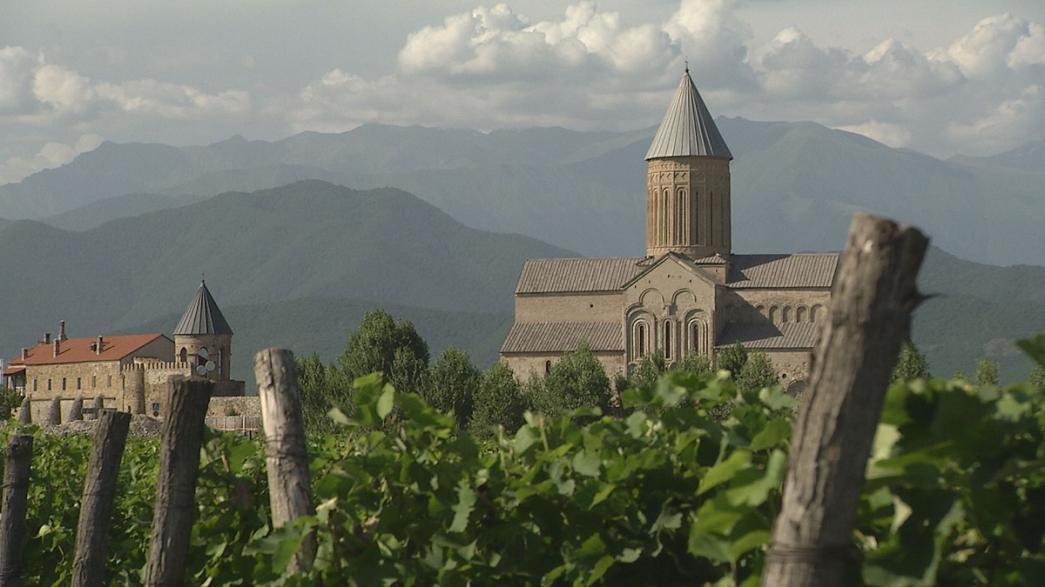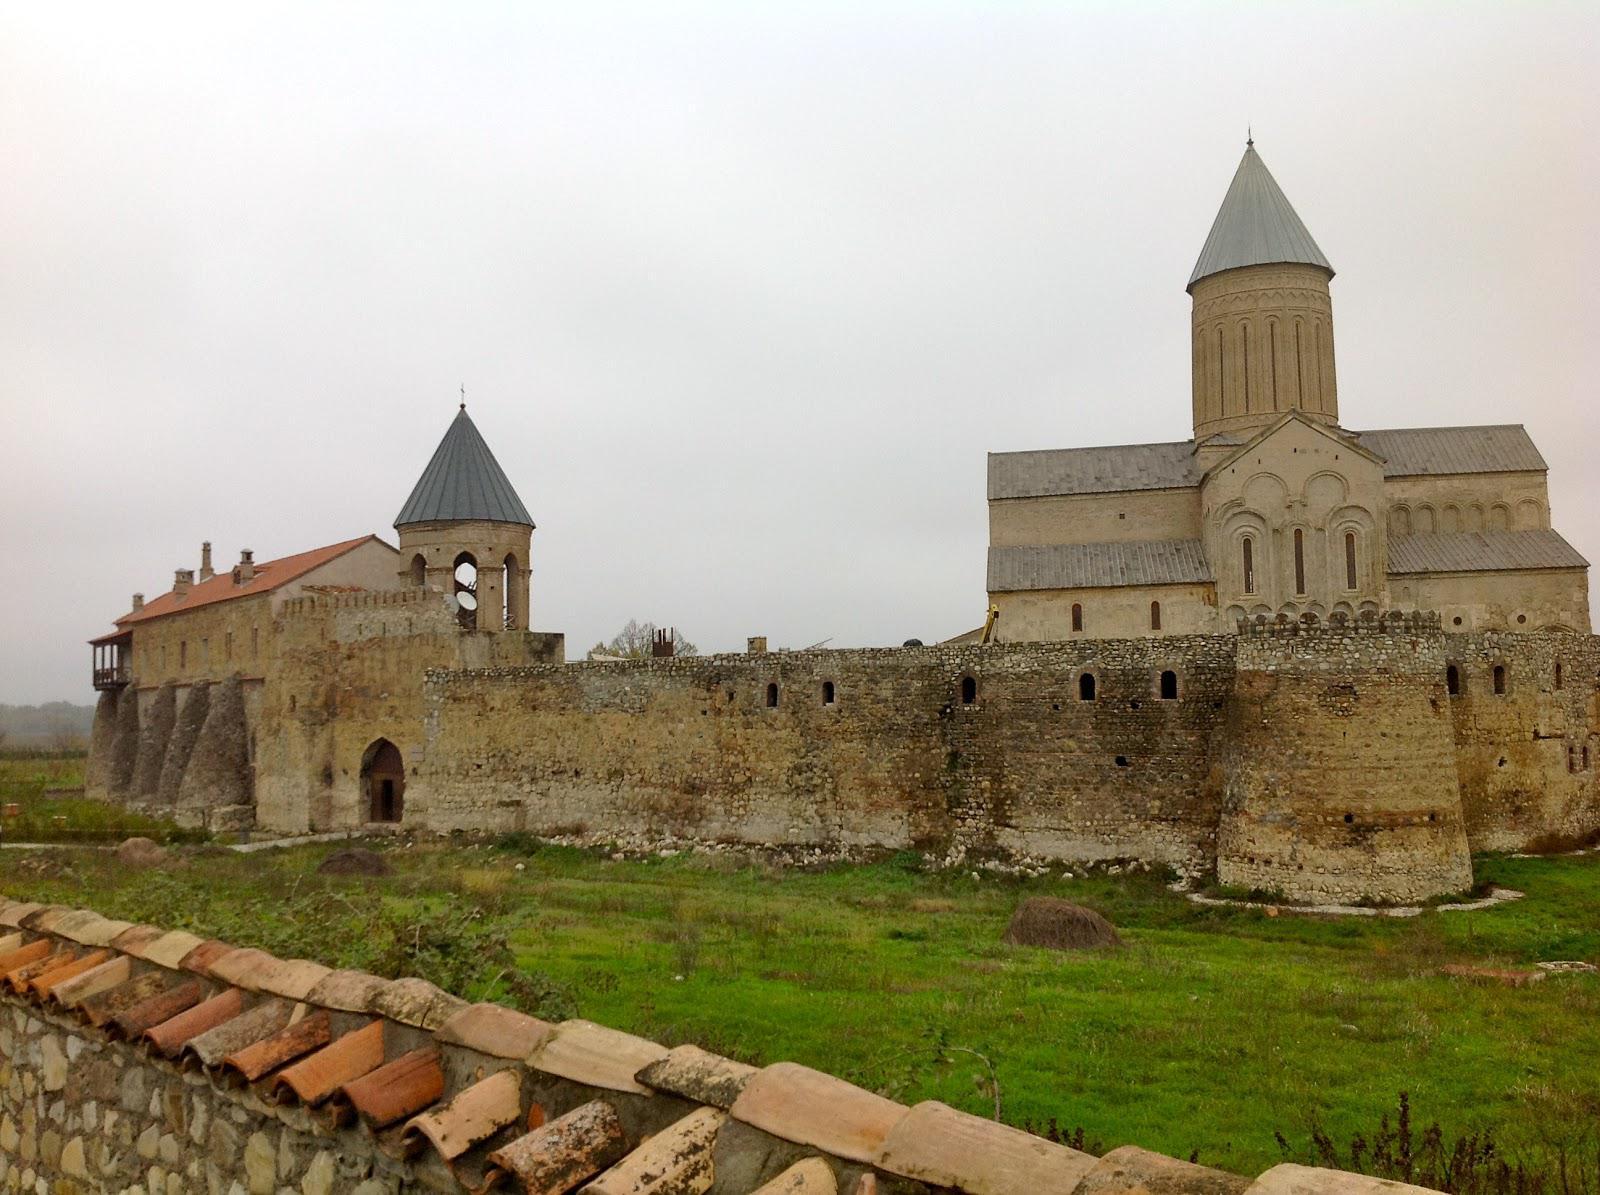The first image is the image on the left, the second image is the image on the right. Analyze the images presented: Is the assertion "In at least one image there are at least two triangle towers roofs behind a cobblestone wall." valid? Answer yes or no. Yes. The first image is the image on the left, the second image is the image on the right. For the images displayed, is the sentence "There is a stone wall in front of the building in one image, but no stone wall in front of the other." factually correct? Answer yes or no. Yes. 